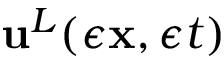<formula> <loc_0><loc_0><loc_500><loc_500>{ u } ^ { L } ( \epsilon { x } , \epsilon t )</formula> 